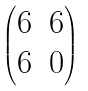Convert formula to latex. <formula><loc_0><loc_0><loc_500><loc_500>\begin{pmatrix} 6 & 6 \\ 6 & 0 \end{pmatrix}</formula> 